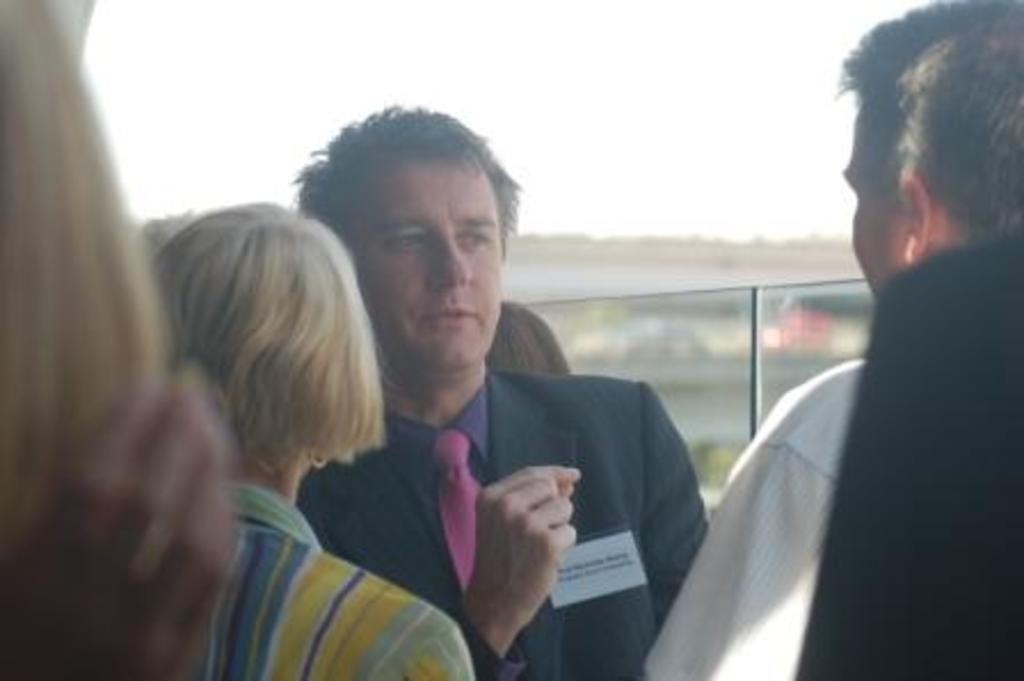Who or what is present in the image? There are people in the image. How are the people arranged in the image? The people are positioned from left to right. What object can be seen in the image besides the people? There is a glass in the image. Can you describe the background of the image? The background of the image is blurry. What type of secretary can be seen working in the image? There is no secretary present in the image; it only features people and a glass. What thrilling activity is taking place in the image? There is no thrilling activity depicted in the image; it is a simple scene with people and a glass. 